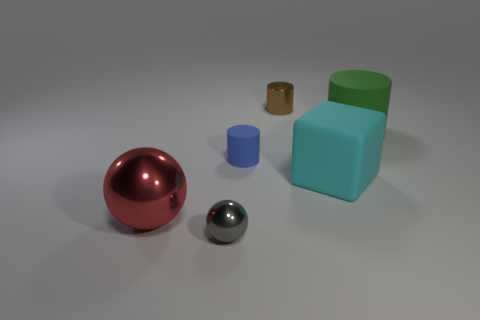There is a big rubber object behind the tiny blue object; is its shape the same as the matte object left of the small brown object?
Your answer should be compact. Yes. How many other things are the same size as the green matte object?
Your answer should be very brief. 2. Is the number of big green matte cylinders that are left of the blue object less than the number of rubber things that are to the left of the small brown metal thing?
Your answer should be very brief. Yes. There is a metal object that is both left of the brown metallic cylinder and behind the small shiny sphere; what color is it?
Make the answer very short. Red. There is a gray thing; is its size the same as the metal ball that is to the left of the gray shiny ball?
Your response must be concise. No. What shape is the large thing left of the large cube?
Provide a succinct answer. Sphere. Is the number of metal objects in front of the brown cylinder greater than the number of green cylinders?
Your answer should be compact. Yes. There is a large object that is behind the big matte thing left of the big cylinder; what number of blue rubber cylinders are left of it?
Your answer should be very brief. 1. There is a metal object that is to the right of the blue matte object; is its size the same as the matte object right of the large rubber cube?
Ensure brevity in your answer.  No. What material is the tiny cylinder that is in front of the large matte thing that is behind the cyan matte thing made of?
Offer a terse response. Rubber. 